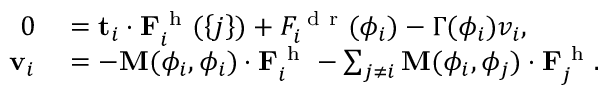<formula> <loc_0><loc_0><loc_500><loc_500>\begin{array} { r l } { 0 } & = t _ { i } \cdot F _ { i } ^ { h } ( \left \{ j \right \} ) + F _ { i } ^ { d r } ( \phi _ { i } ) - \Gamma ( \phi _ { i } ) v _ { i } , } \\ { v _ { i } } & = - M ( \phi _ { i } , \phi _ { i } ) \cdot F _ { i } ^ { h } - \sum _ { j \ne i } M ( \phi _ { i } , \phi _ { j } ) \cdot F _ { j } ^ { h } . } \end{array}</formula> 